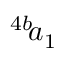<formula> <loc_0><loc_0><loc_500><loc_500>^ { 4 b } \, a _ { 1 }</formula> 